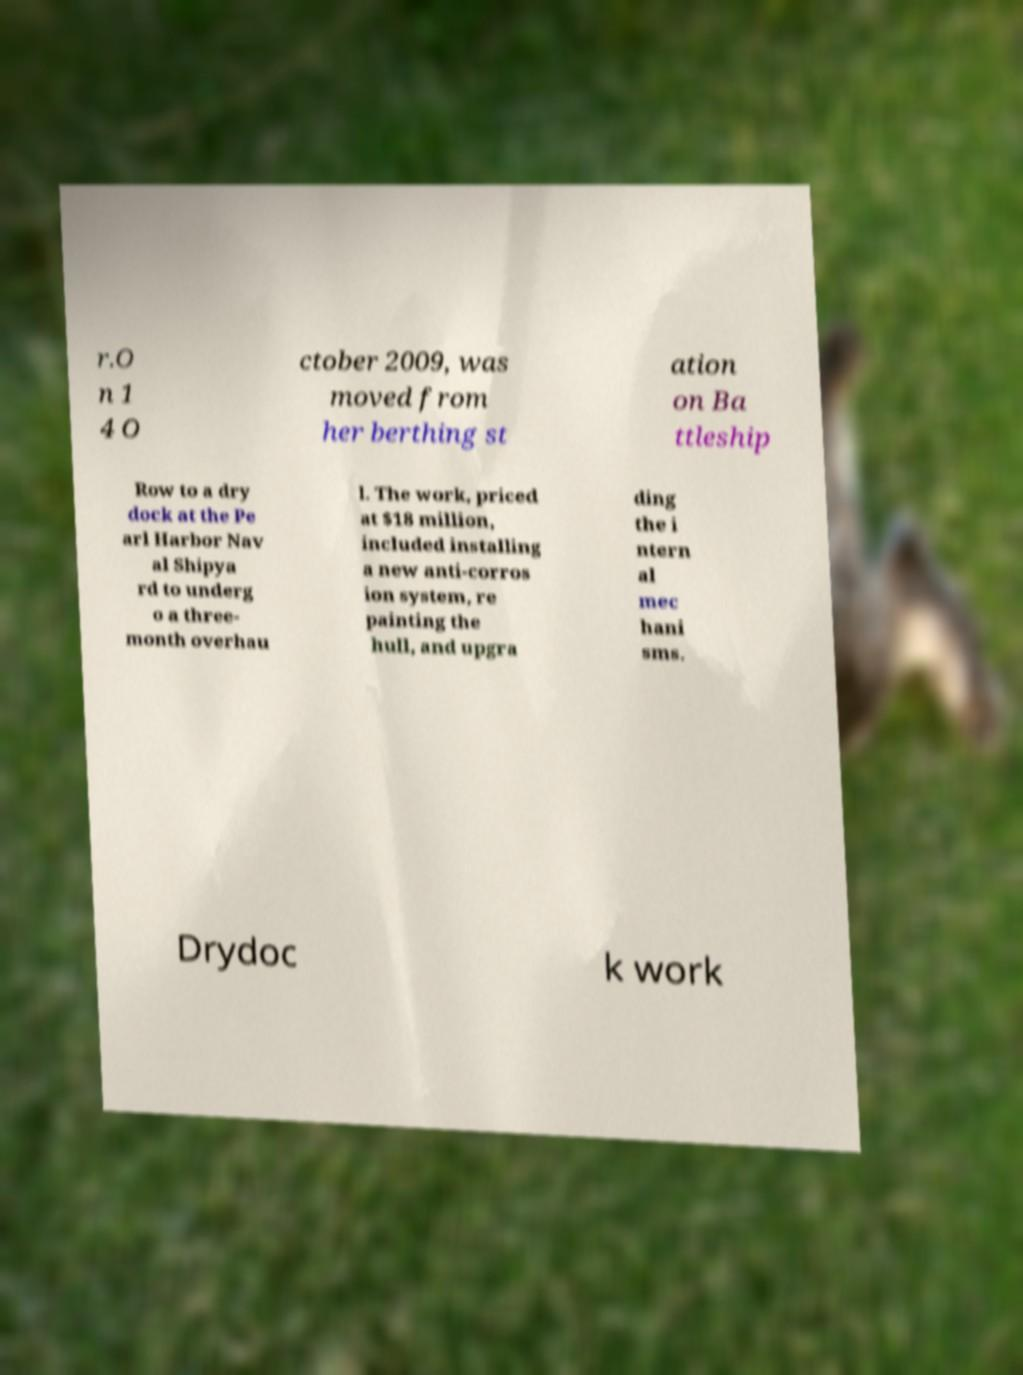Can you read and provide the text displayed in the image?This photo seems to have some interesting text. Can you extract and type it out for me? r.O n 1 4 O ctober 2009, was moved from her berthing st ation on Ba ttleship Row to a dry dock at the Pe arl Harbor Nav al Shipya rd to underg o a three- month overhau l. The work, priced at $18 million, included installing a new anti-corros ion system, re painting the hull, and upgra ding the i ntern al mec hani sms. Drydoc k work 